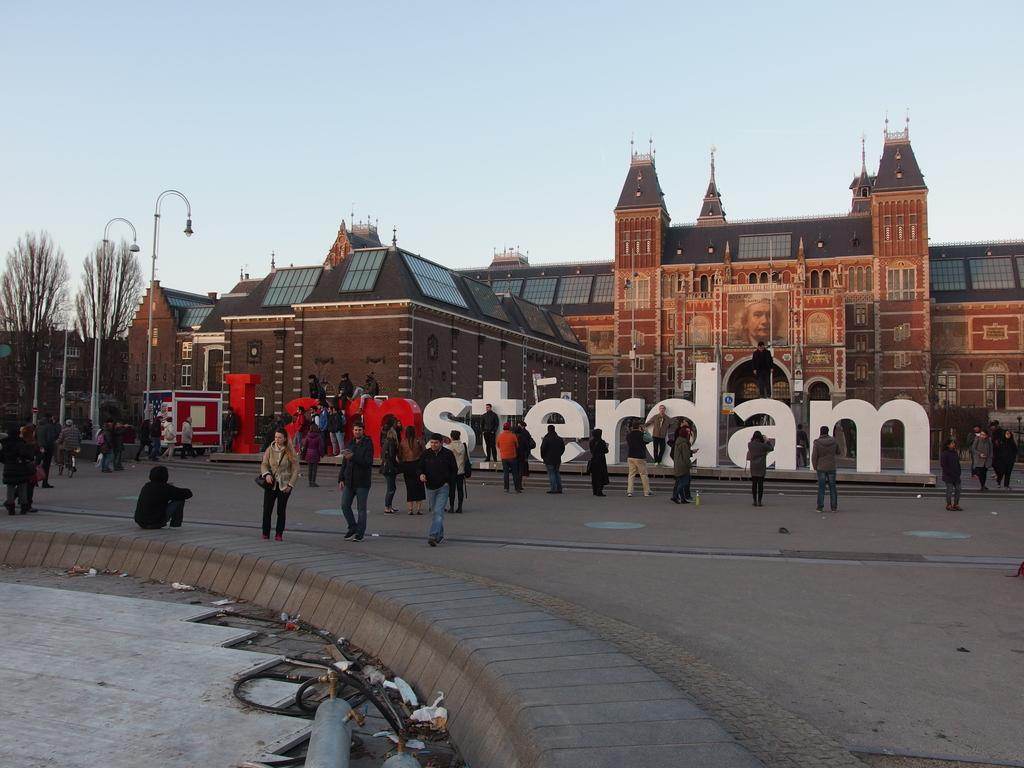What type of structures can be seen in the image? There are buildings in the image. What is located in front of the buildings? There are trees and lampposts in front of the buildings. What is the purpose of the lampposts? The lampposts are likely for providing light. What is the logo in the image? There is a logo in the image, but we cannot determine its meaning or purpose from the image alone. What is happening in front of the logo? There are people walking in front of the logo. What is the father doing with the kitten in the image? There is no father or kitten present in the image. 